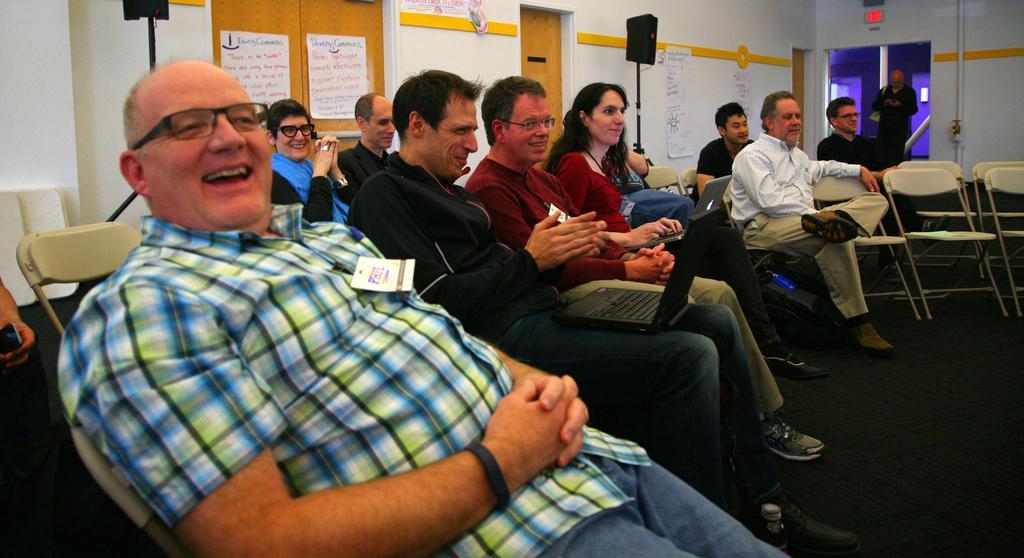Can you describe this image briefly? Few persons are sitting on the chairs and this person standing,these two persons are holding laptops. This is floor. On the background we can see wall,speakers with stands,papers. 